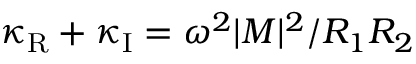Convert formula to latex. <formula><loc_0><loc_0><loc_500><loc_500>\kappa _ { R } + \kappa _ { I } = \omega ^ { 2 } | M | ^ { 2 } / R _ { 1 } R _ { 2 }</formula> 